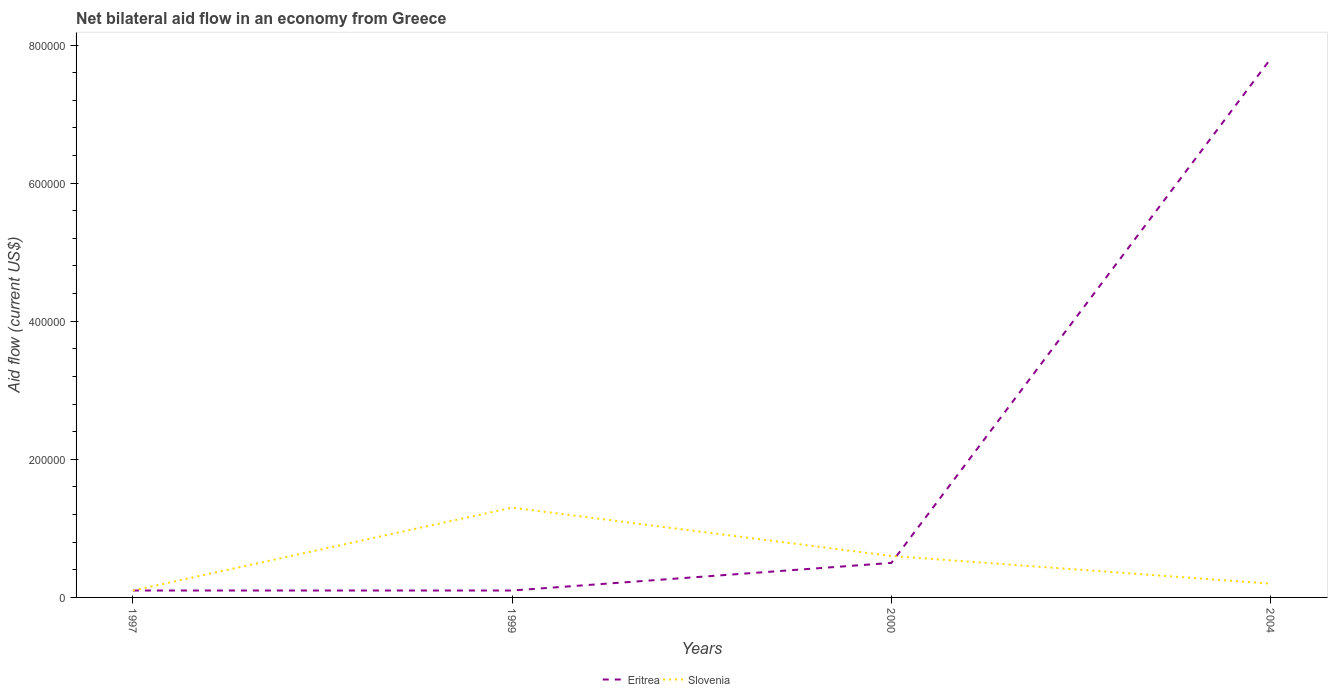Is the number of lines equal to the number of legend labels?
Offer a very short reply. Yes. Across all years, what is the maximum net bilateral aid flow in Eritrea?
Offer a terse response. 10000. What is the total net bilateral aid flow in Eritrea in the graph?
Offer a terse response. -4.00e+04. What is the difference between the highest and the second highest net bilateral aid flow in Eritrea?
Your answer should be very brief. 7.70e+05. What is the difference between the highest and the lowest net bilateral aid flow in Slovenia?
Your answer should be very brief. 2. Is the net bilateral aid flow in Slovenia strictly greater than the net bilateral aid flow in Eritrea over the years?
Your answer should be very brief. No. How many years are there in the graph?
Your answer should be compact. 4. Does the graph contain grids?
Offer a terse response. No. Where does the legend appear in the graph?
Make the answer very short. Bottom center. How many legend labels are there?
Provide a succinct answer. 2. How are the legend labels stacked?
Offer a very short reply. Horizontal. What is the title of the graph?
Your answer should be very brief. Net bilateral aid flow in an economy from Greece. Does "Andorra" appear as one of the legend labels in the graph?
Give a very brief answer. No. What is the label or title of the X-axis?
Offer a terse response. Years. What is the label or title of the Y-axis?
Offer a very short reply. Aid flow (current US$). What is the Aid flow (current US$) in Eritrea in 2000?
Your response must be concise. 5.00e+04. What is the Aid flow (current US$) in Eritrea in 2004?
Give a very brief answer. 7.80e+05. What is the Aid flow (current US$) of Slovenia in 2004?
Offer a terse response. 2.00e+04. Across all years, what is the maximum Aid flow (current US$) in Eritrea?
Provide a short and direct response. 7.80e+05. Across all years, what is the minimum Aid flow (current US$) in Eritrea?
Your answer should be very brief. 10000. Across all years, what is the minimum Aid flow (current US$) in Slovenia?
Your answer should be compact. 10000. What is the total Aid flow (current US$) of Eritrea in the graph?
Keep it short and to the point. 8.50e+05. What is the total Aid flow (current US$) of Slovenia in the graph?
Your answer should be compact. 2.20e+05. What is the difference between the Aid flow (current US$) of Eritrea in 1997 and that in 2000?
Ensure brevity in your answer.  -4.00e+04. What is the difference between the Aid flow (current US$) of Slovenia in 1997 and that in 2000?
Ensure brevity in your answer.  -5.00e+04. What is the difference between the Aid flow (current US$) of Eritrea in 1997 and that in 2004?
Provide a short and direct response. -7.70e+05. What is the difference between the Aid flow (current US$) of Slovenia in 1997 and that in 2004?
Ensure brevity in your answer.  -10000. What is the difference between the Aid flow (current US$) of Eritrea in 1999 and that in 2004?
Your answer should be very brief. -7.70e+05. What is the difference between the Aid flow (current US$) in Eritrea in 2000 and that in 2004?
Offer a terse response. -7.30e+05. What is the difference between the Aid flow (current US$) of Eritrea in 1997 and the Aid flow (current US$) of Slovenia in 1999?
Offer a very short reply. -1.20e+05. What is the difference between the Aid flow (current US$) in Eritrea in 1997 and the Aid flow (current US$) in Slovenia in 2000?
Provide a short and direct response. -5.00e+04. What is the average Aid flow (current US$) of Eritrea per year?
Your answer should be compact. 2.12e+05. What is the average Aid flow (current US$) of Slovenia per year?
Give a very brief answer. 5.50e+04. In the year 1999, what is the difference between the Aid flow (current US$) in Eritrea and Aid flow (current US$) in Slovenia?
Your response must be concise. -1.20e+05. In the year 2000, what is the difference between the Aid flow (current US$) of Eritrea and Aid flow (current US$) of Slovenia?
Your answer should be compact. -10000. In the year 2004, what is the difference between the Aid flow (current US$) in Eritrea and Aid flow (current US$) in Slovenia?
Offer a terse response. 7.60e+05. What is the ratio of the Aid flow (current US$) in Slovenia in 1997 to that in 1999?
Provide a succinct answer. 0.08. What is the ratio of the Aid flow (current US$) of Slovenia in 1997 to that in 2000?
Provide a succinct answer. 0.17. What is the ratio of the Aid flow (current US$) in Eritrea in 1997 to that in 2004?
Provide a short and direct response. 0.01. What is the ratio of the Aid flow (current US$) in Slovenia in 1997 to that in 2004?
Provide a succinct answer. 0.5. What is the ratio of the Aid flow (current US$) of Slovenia in 1999 to that in 2000?
Your answer should be compact. 2.17. What is the ratio of the Aid flow (current US$) of Eritrea in 1999 to that in 2004?
Your answer should be compact. 0.01. What is the ratio of the Aid flow (current US$) of Slovenia in 1999 to that in 2004?
Provide a succinct answer. 6.5. What is the ratio of the Aid flow (current US$) in Eritrea in 2000 to that in 2004?
Your answer should be very brief. 0.06. What is the difference between the highest and the second highest Aid flow (current US$) in Eritrea?
Offer a very short reply. 7.30e+05. What is the difference between the highest and the second highest Aid flow (current US$) of Slovenia?
Give a very brief answer. 7.00e+04. What is the difference between the highest and the lowest Aid flow (current US$) of Eritrea?
Give a very brief answer. 7.70e+05. 